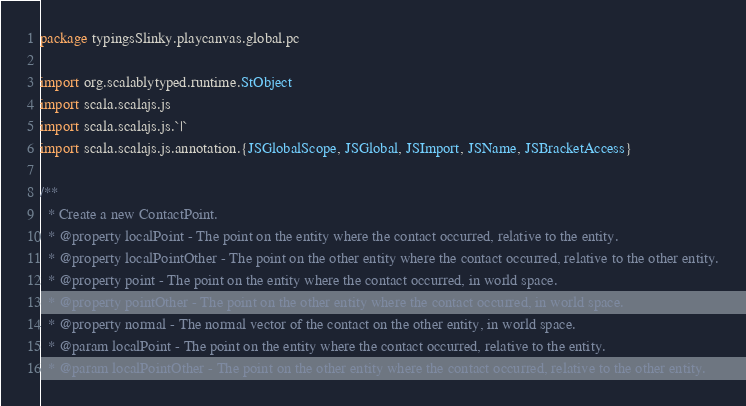<code> <loc_0><loc_0><loc_500><loc_500><_Scala_>package typingsSlinky.playcanvas.global.pc

import org.scalablytyped.runtime.StObject
import scala.scalajs.js
import scala.scalajs.js.`|`
import scala.scalajs.js.annotation.{JSGlobalScope, JSGlobal, JSImport, JSName, JSBracketAccess}

/**
  * Create a new ContactPoint.
  * @property localPoint - The point on the entity where the contact occurred, relative to the entity.
  * @property localPointOther - The point on the other entity where the contact occurred, relative to the other entity.
  * @property point - The point on the entity where the contact occurred, in world space.
  * @property pointOther - The point on the other entity where the contact occurred, in world space.
  * @property normal - The normal vector of the contact on the other entity, in world space.
  * @param localPoint - The point on the entity where the contact occurred, relative to the entity.
  * @param localPointOther - The point on the other entity where the contact occurred, relative to the other entity.</code> 